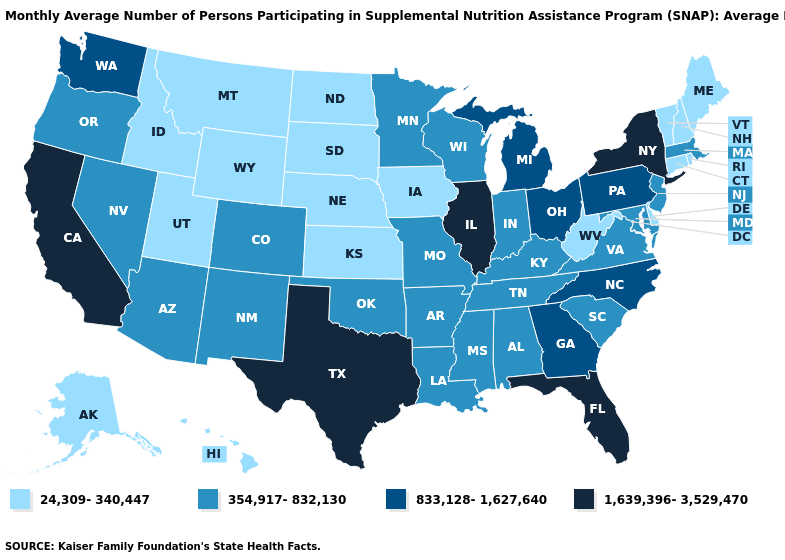Name the states that have a value in the range 1,639,396-3,529,470?
Write a very short answer. California, Florida, Illinois, New York, Texas. Name the states that have a value in the range 1,639,396-3,529,470?
Answer briefly. California, Florida, Illinois, New York, Texas. Does Nevada have the lowest value in the West?
Be succinct. No. Does California have a higher value than Louisiana?
Quick response, please. Yes. What is the value of Colorado?
Short answer required. 354,917-832,130. What is the value of Louisiana?
Concise answer only. 354,917-832,130. Does Louisiana have a lower value than Pennsylvania?
Write a very short answer. Yes. Which states have the lowest value in the South?
Write a very short answer. Delaware, West Virginia. Which states hav the highest value in the South?
Keep it brief. Florida, Texas. Name the states that have a value in the range 24,309-340,447?
Write a very short answer. Alaska, Connecticut, Delaware, Hawaii, Idaho, Iowa, Kansas, Maine, Montana, Nebraska, New Hampshire, North Dakota, Rhode Island, South Dakota, Utah, Vermont, West Virginia, Wyoming. Name the states that have a value in the range 833,128-1,627,640?
Give a very brief answer. Georgia, Michigan, North Carolina, Ohio, Pennsylvania, Washington. What is the value of Michigan?
Concise answer only. 833,128-1,627,640. Does Colorado have a lower value than North Dakota?
Give a very brief answer. No. What is the value of Oklahoma?
Keep it brief. 354,917-832,130. Does the map have missing data?
Write a very short answer. No. 